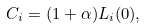<formula> <loc_0><loc_0><loc_500><loc_500>C _ { i } = ( 1 + \alpha ) L _ { i } ( 0 ) ,</formula> 